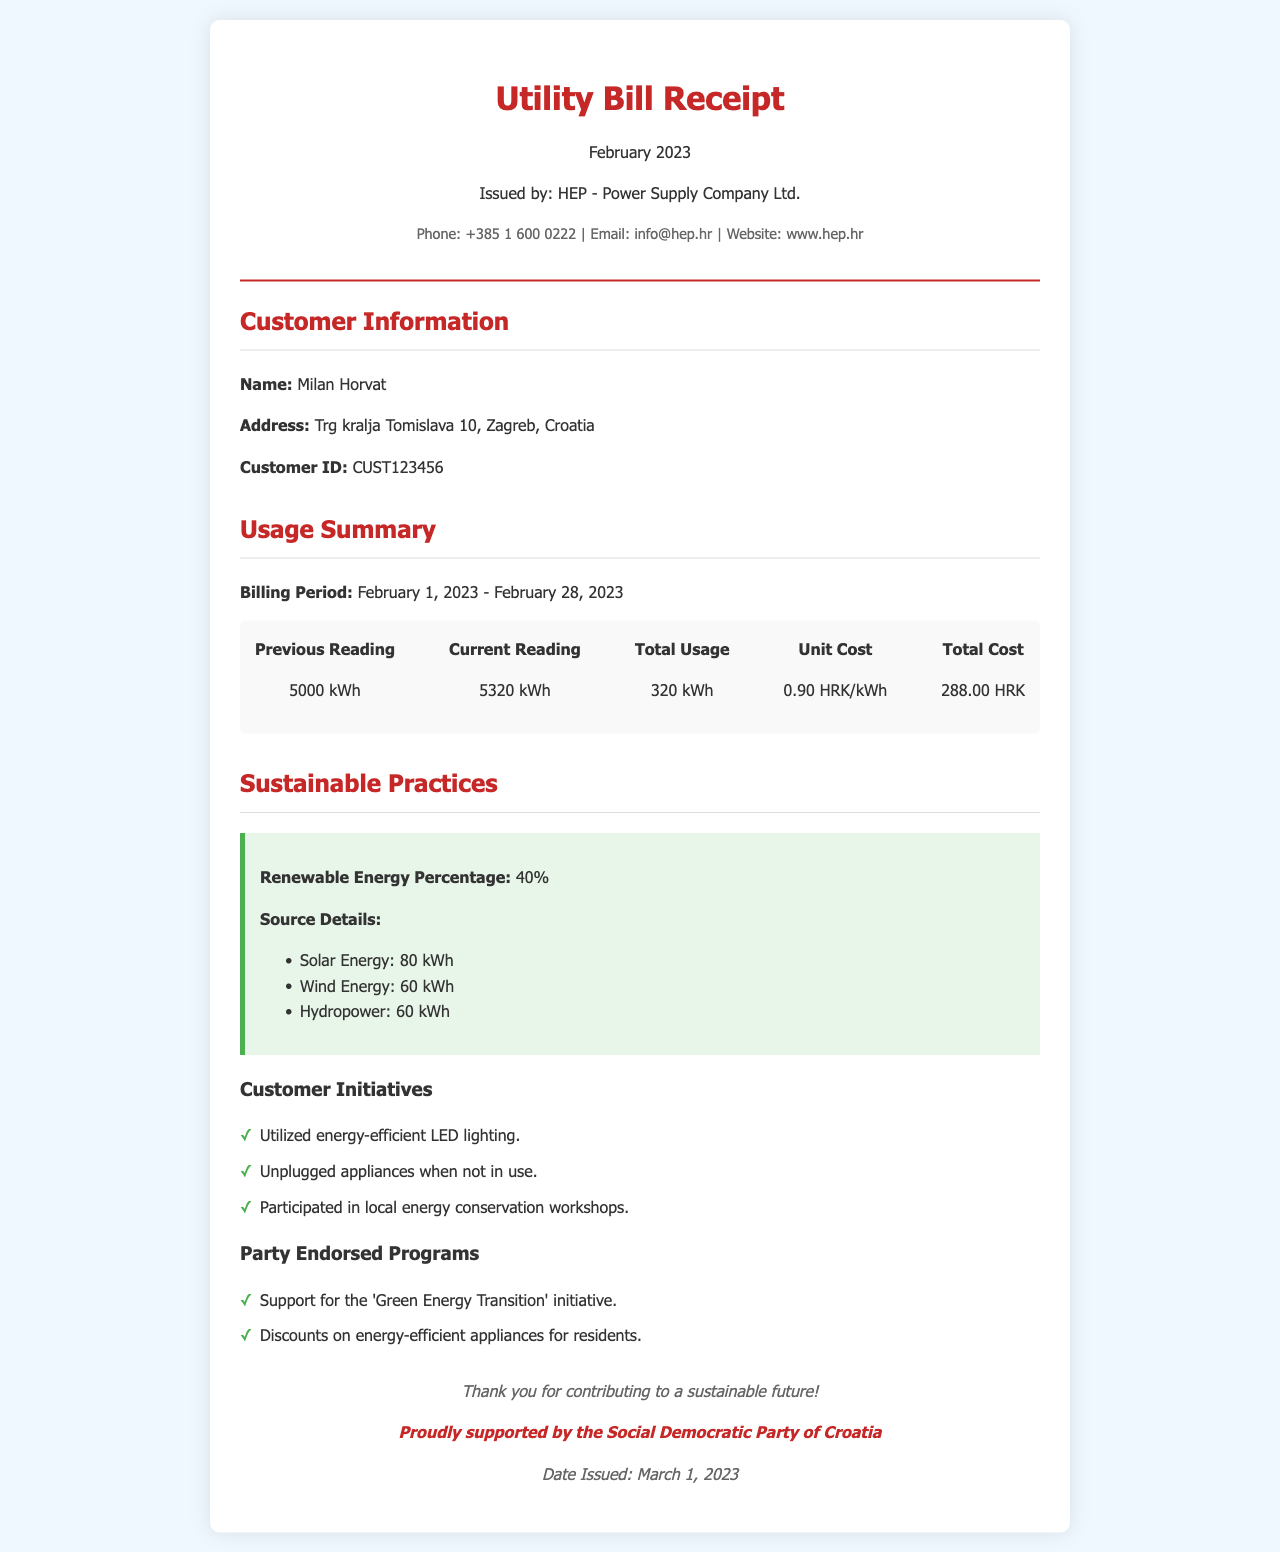What is the customer ID? The customer ID is listed in the customer information section of the document.
Answer: CUST123456 What is the total usage for February? The total usage is calculated by taking the difference between the current and previous readings.
Answer: 320 kWh What is the unit cost of energy? The unit cost can be found in the usage summary section of the document.
Answer: 0.90 HRK/kWh What is the renewable energy percentage? The renewable energy percentage is highlighted in the sustainable practices section.
Answer: 40% Which energy sources contributed to the renewable energy? The sources of renewable energy are detailed under the renewable energy section.
Answer: Solar Energy, Wind Energy, Hydropower How much did the total cost amount to? The total cost can be found in the usage summary section of the document.
Answer: 288.00 HRK What initiatives has the customer undertaken? The customer's initiatives are listed under the customer initiatives section.
Answer: Utilized energy-efficient LED lighting, Unplugged appliances when not in use, Participated in local energy conservation workshops What is the name of the power supply company? The power supply company is mentioned in the header of the document.
Answer: HEP - Power Supply Company Ltd What is the date issued, according to the document? The date issued is located in the footer of the document.
Answer: March 1, 2023 